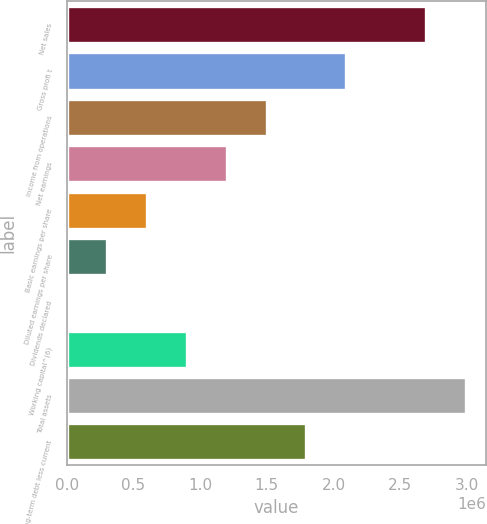<chart> <loc_0><loc_0><loc_500><loc_500><bar_chart><fcel>Net sales<fcel>Gross profi t<fcel>Income from operations<fcel>Net earnings<fcel>Basic earnings per share<fcel>Diluted earnings per share<fcel>Dividends declared<fcel>Working capital^(6)<fcel>Total assets<fcel>Long-term debt less current<nl><fcel>2.69582e+06<fcel>2.09675e+06<fcel>1.49768e+06<fcel>1.19814e+06<fcel>599072<fcel>299536<fcel>0.24<fcel>898608<fcel>2.99536e+06<fcel>1.79722e+06<nl></chart> 